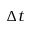<formula> <loc_0><loc_0><loc_500><loc_500>\Delta t</formula> 